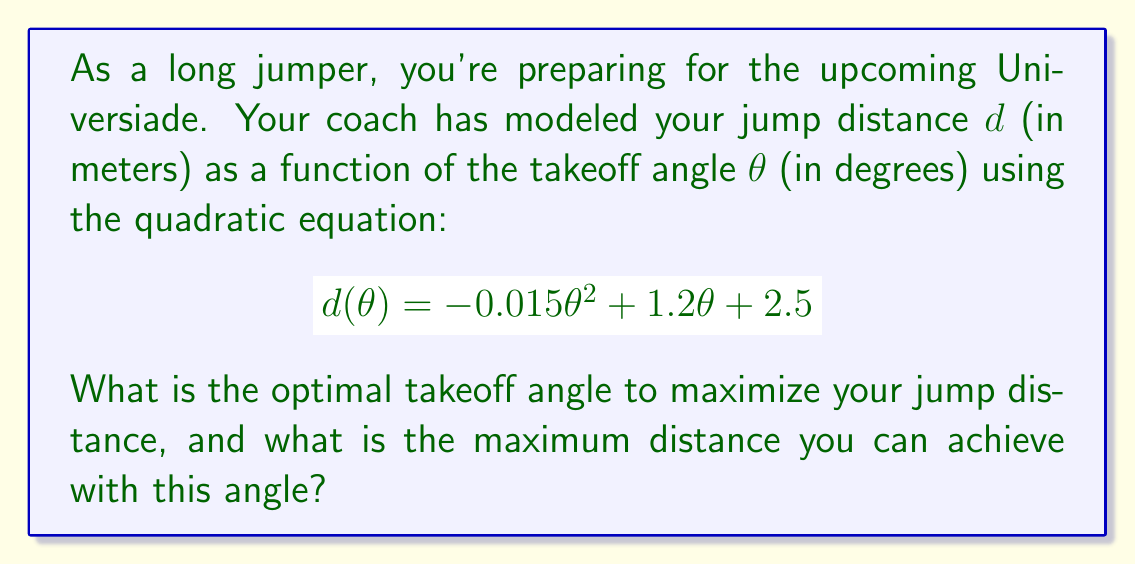Show me your answer to this math problem. To solve this problem, we'll follow these steps:

1) The quadratic equation given is in the form $f(x) = ax^2 + bx + c$, where:
   $a = -0.015$
   $b = 1.2$
   $c = 2.5$

2) For a quadratic function, the x-coordinate of the vertex represents the value of x that maximizes (or minimizes) the function. In this case, it will give us the optimal angle.

3) The formula for the x-coordinate of the vertex is: $x = -\frac{b}{2a}$

4) Substituting our values:
   $$\theta_{optimal} = -\frac{1.2}{2(-0.015)} = -\frac{1.2}{-0.03} = 40$$

5) To find the maximum distance, we substitute this optimal angle into our original equation:

   $$d(40) = -0.015(40)^2 + 1.2(40) + 2.5$$
   $$= -0.015(1600) + 48 + 2.5$$
   $$= -24 + 48 + 2.5$$
   $$= 26.5$$

Therefore, the optimal takeoff angle is 40 degrees, and the maximum distance achieved at this angle is 26.5 meters.
Answer: The optimal takeoff angle is 40 degrees, and the maximum jump distance is 26.5 meters. 